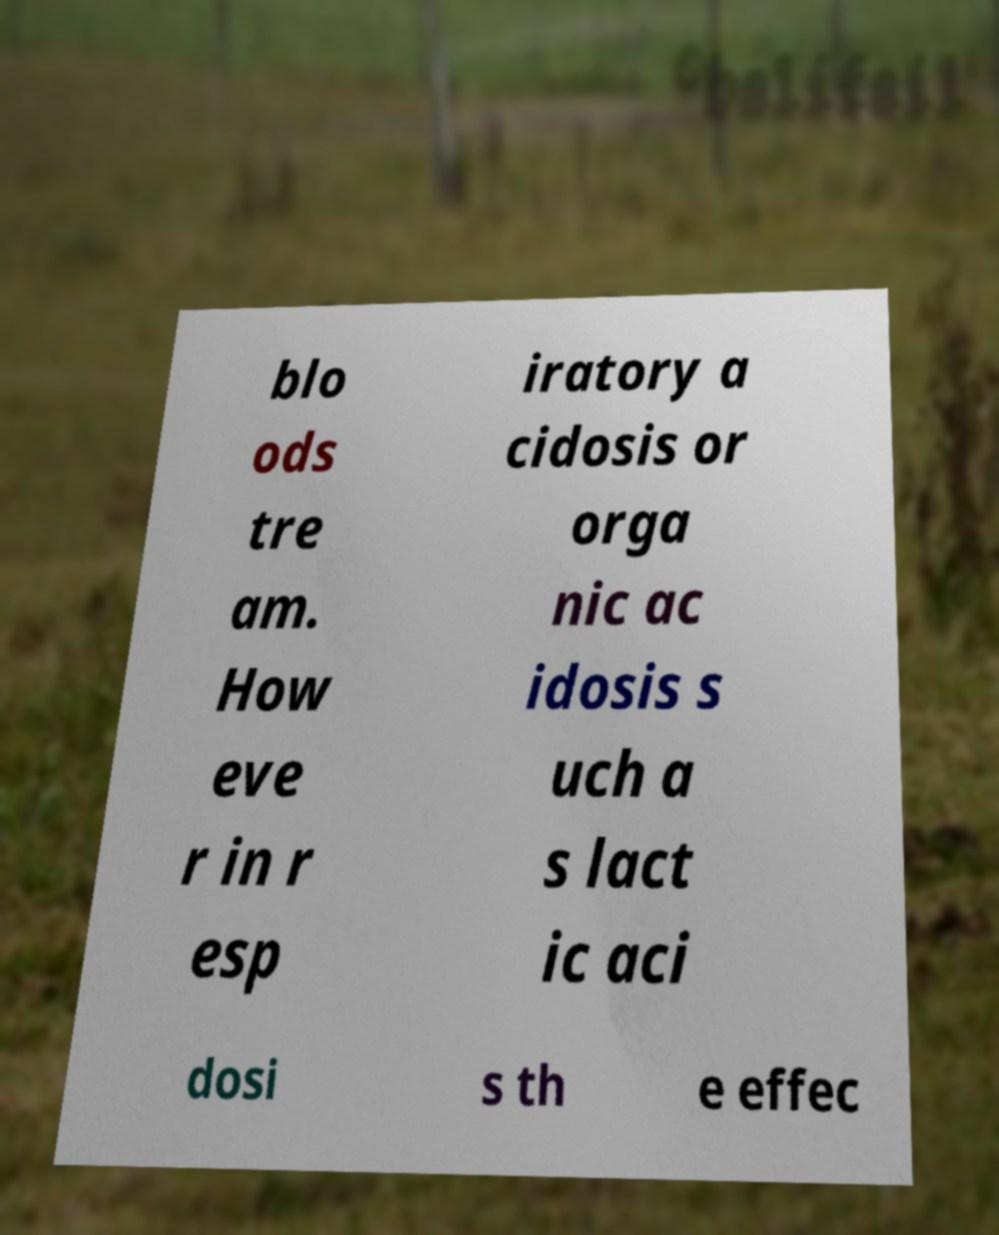For documentation purposes, I need the text within this image transcribed. Could you provide that? blo ods tre am. How eve r in r esp iratory a cidosis or orga nic ac idosis s uch a s lact ic aci dosi s th e effec 